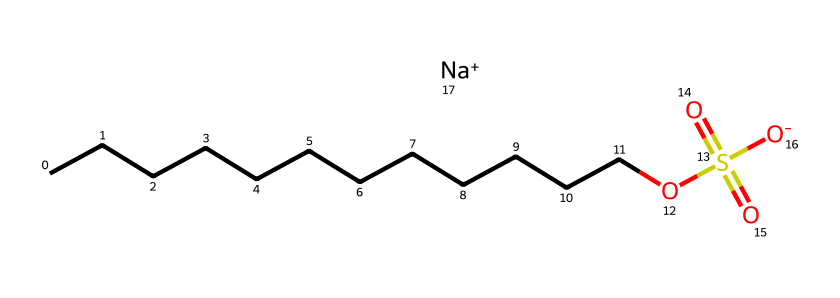What is the total number of carbon atoms in sodium lauryl sulfate? The chemical formula represented in the SMILES structure shows a long carbon chain indicated by the "CCCCCCCCCCCC". Counting these carbon atoms gives a total of 12.
Answer: 12 Which functional group is present in sodium lauryl sulfate? The presence of "OS(=O)(=O)[O-]" in the SMILES indicates the sulfate functional group due to the sulfur atom bonded to oxygen atoms and a negatively charged oxygen.
Answer: sulfate How many sodium ions are associated with this compound? The "[Na+]" in the SMILES structure indicates there is one sodium ion associated with the structure.
Answer: 1 What type of chemical bonding is primarily observed in sodium lauryl sulfate? The structure shows a long chain of covalently bonded carbon atoms with other functional groups, indicating that covalent bonds are the primary type of bonding.
Answer: covalent Why is sodium lauryl sulfate classified as an anionic surfactant? The compound contains a negatively charged sulfate group which, with its long hydrophobic carbon chain, organizes itself at water interfaces, characteristic of anionic surfactants.
Answer: anionic surfactant 